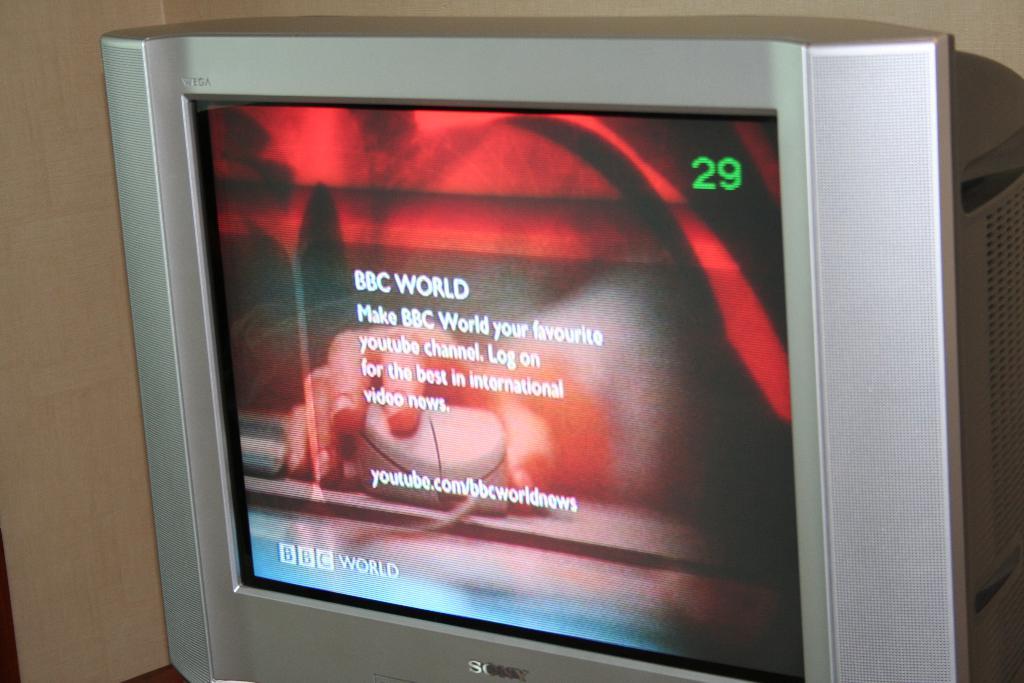What channel is the tv on?
Offer a very short reply. 29. What is the first word shown on the tv?
Ensure brevity in your answer.  Bbc. 